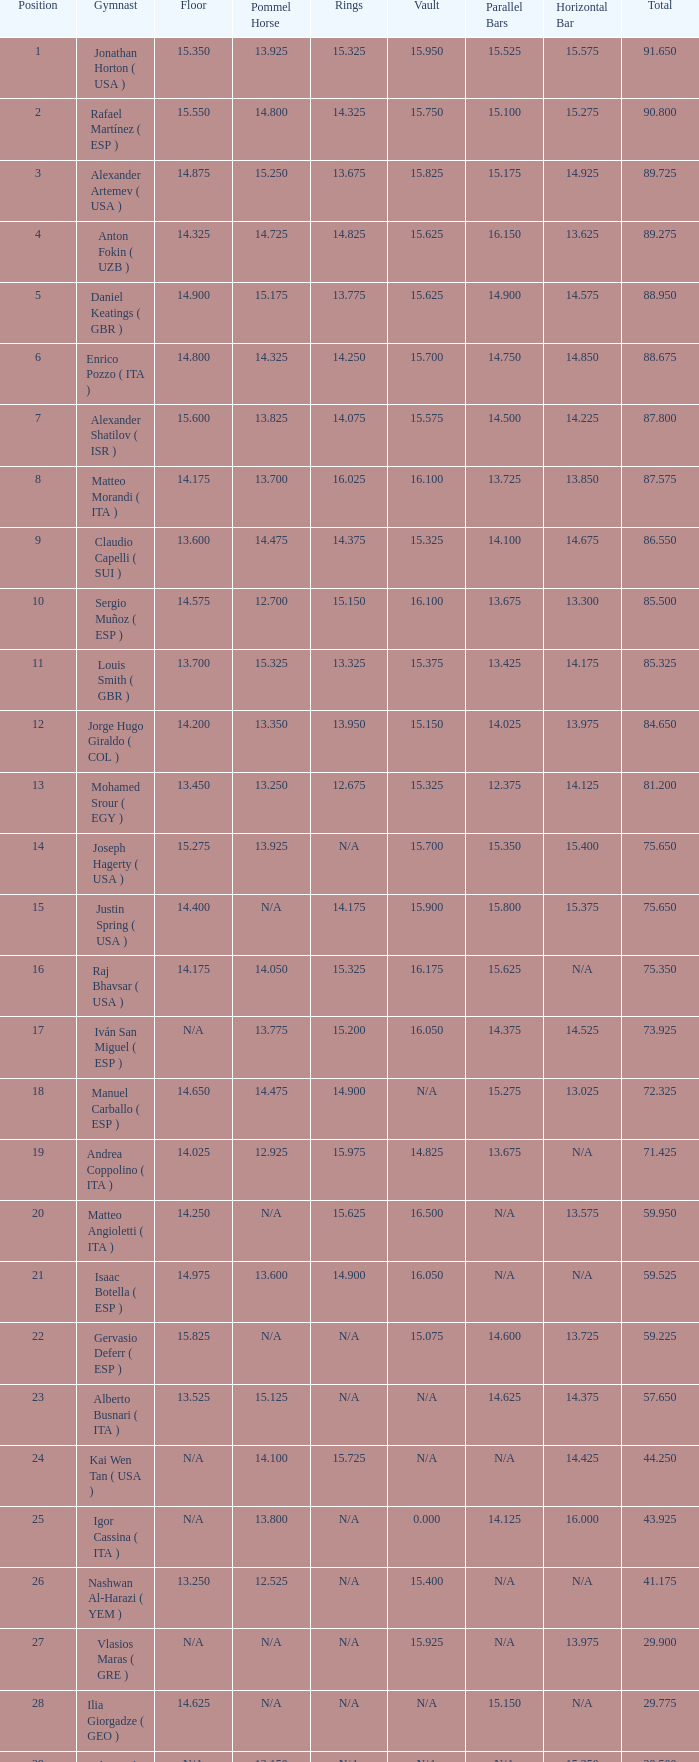If the floor number is 14.200, what is the number for the parallel bars? 14.025. 